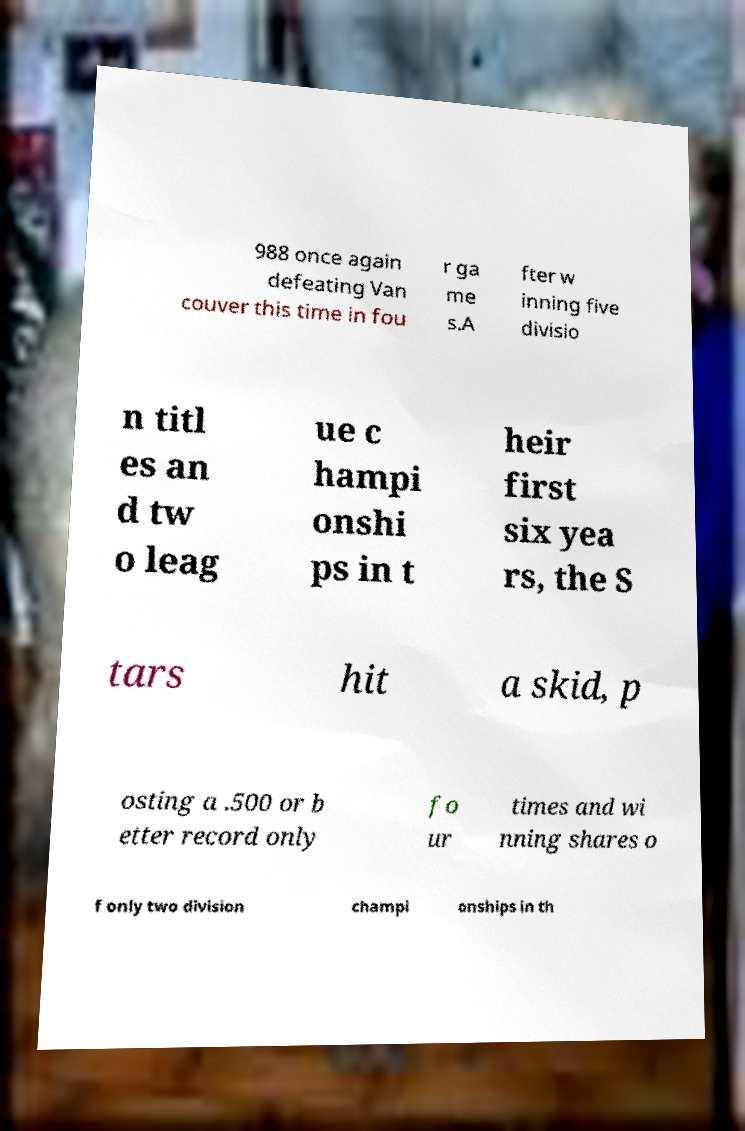Please identify and transcribe the text found in this image. 988 once again defeating Van couver this time in fou r ga me s.A fter w inning five divisio n titl es an d tw o leag ue c hampi onshi ps in t heir first six yea rs, the S tars hit a skid, p osting a .500 or b etter record only fo ur times and wi nning shares o f only two division champi onships in th 